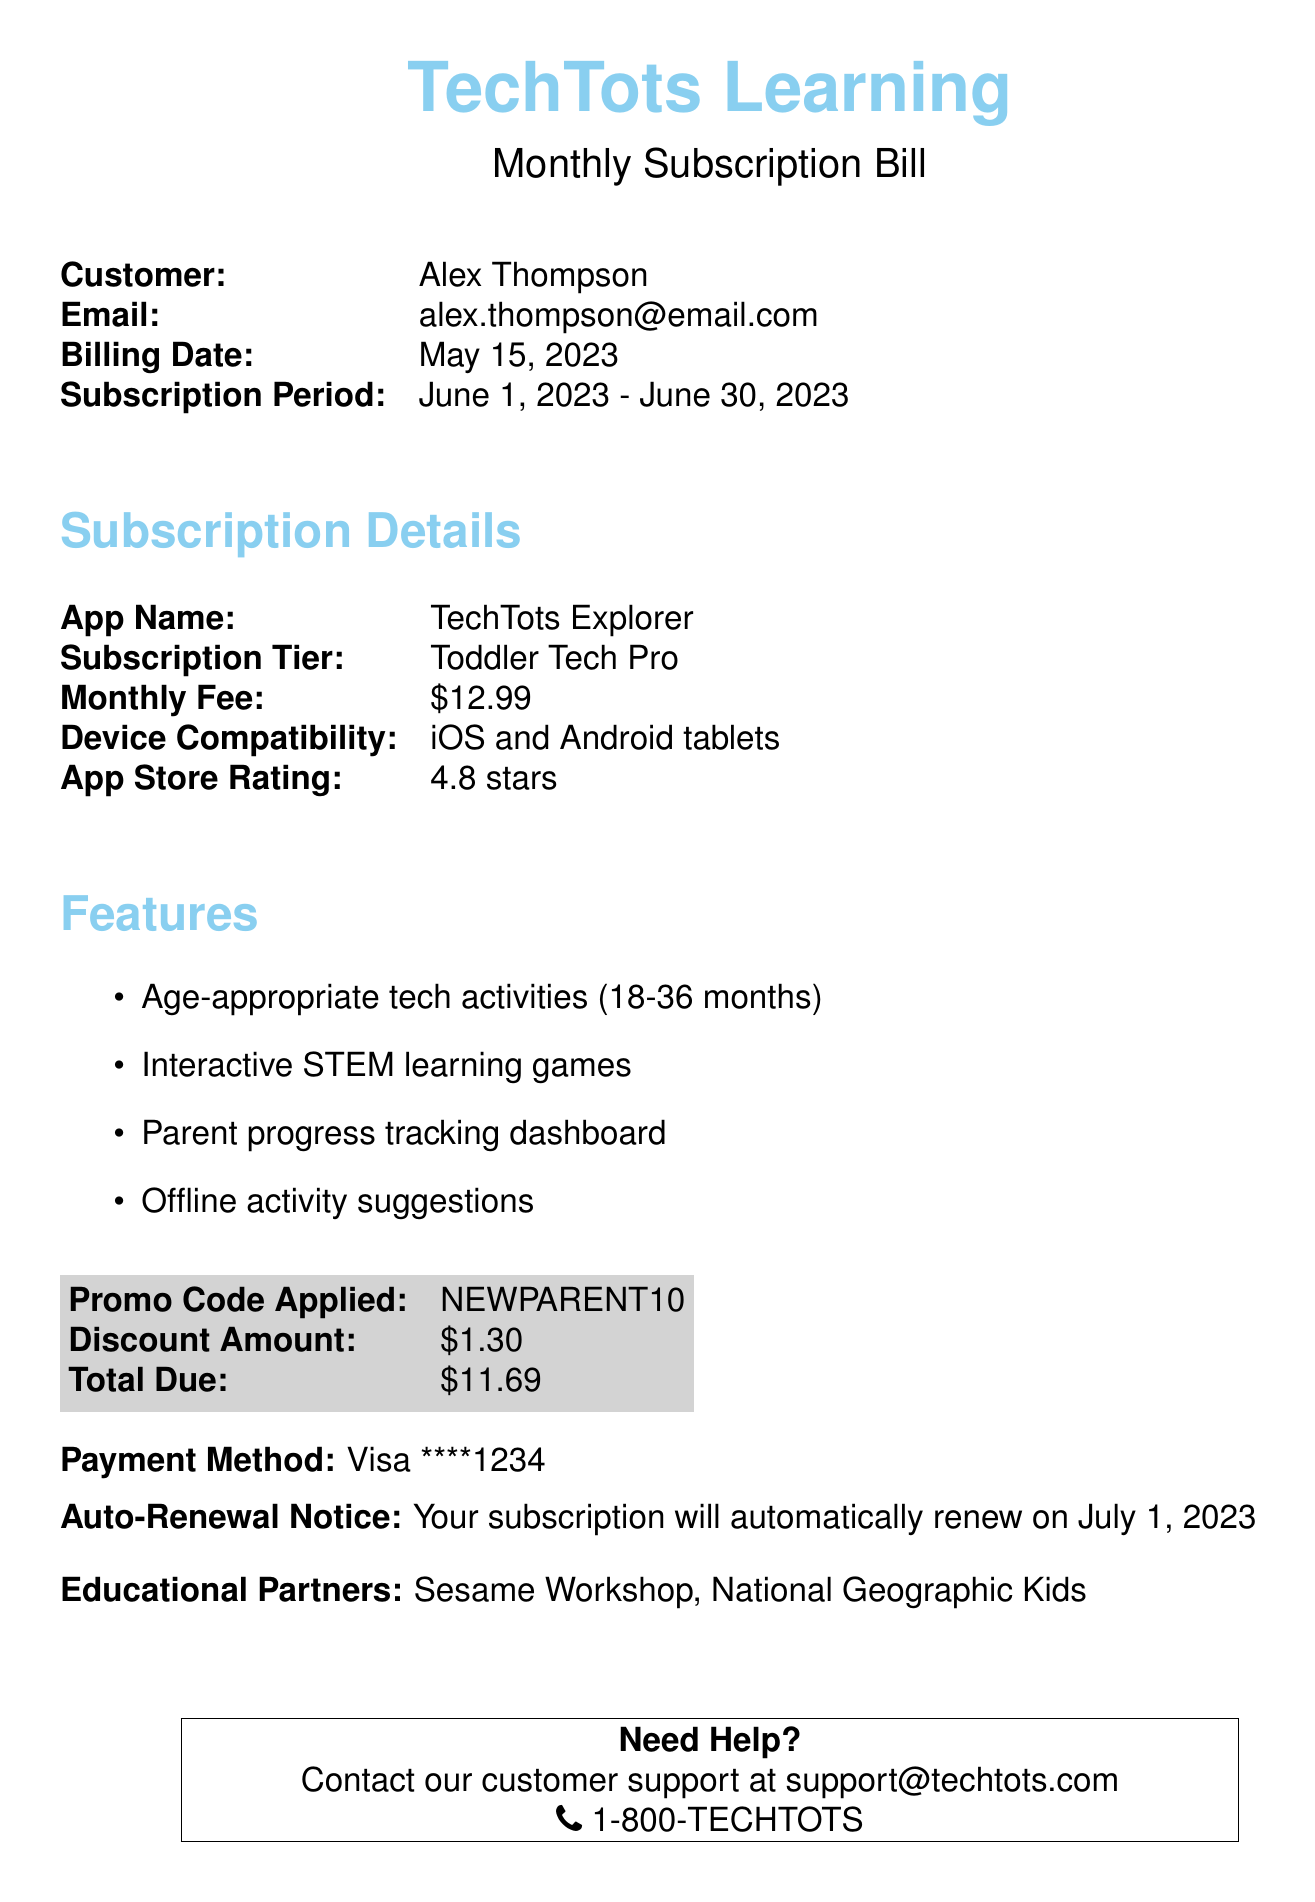What is the customer's name? The customer's name is mentioned at the top of the document.
Answer: Alex Thompson What is the subscription period? The subscription period is specified in a clear range.
Answer: June 1, 2023 - June 30, 2023 What is the monthly fee for the subscription? The monthly fee is listed under subscription details.
Answer: $12.99 What device compatibility is stated for the app? The document includes information about device compatibility for the app.
Answer: iOS and Android tablets What discount was applied to the subscription? The discount amount is provided in the document.
Answer: $1.30 What is the total amount due after the discount? The total due is calculated after applying the discount.
Answer: $11.69 What will happen on July 1, 2023? The document includes an auto-renewal notice.
Answer: Subscription renewal Which educational partners are mentioned? The document lists the educational partners at the bottom.
Answer: Sesame Workshop, National Geographic Kids 